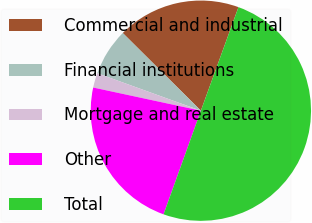<chart> <loc_0><loc_0><loc_500><loc_500><pie_chart><fcel>Commercial and industrial<fcel>Financial institutions<fcel>Mortgage and real estate<fcel>Other<fcel>Total<nl><fcel>18.09%<fcel>6.93%<fcel>2.15%<fcel>22.87%<fcel>49.96%<nl></chart> 